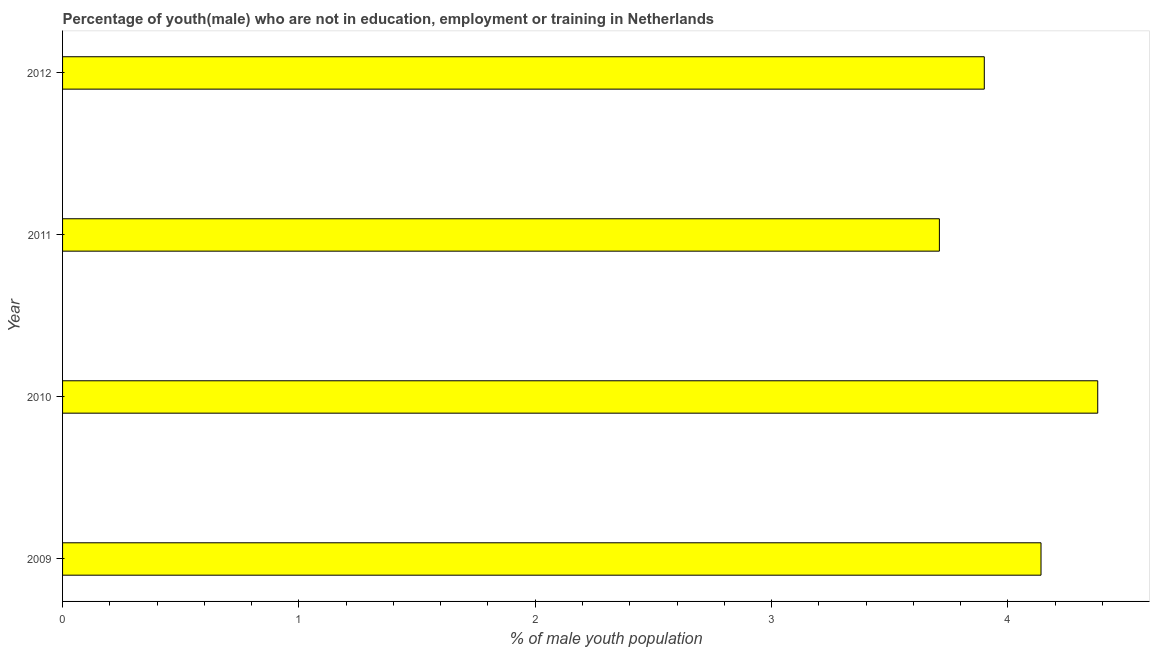What is the title of the graph?
Offer a terse response. Percentage of youth(male) who are not in education, employment or training in Netherlands. What is the label or title of the X-axis?
Give a very brief answer. % of male youth population. What is the label or title of the Y-axis?
Your answer should be very brief. Year. What is the unemployed male youth population in 2011?
Make the answer very short. 3.71. Across all years, what is the maximum unemployed male youth population?
Ensure brevity in your answer.  4.38. Across all years, what is the minimum unemployed male youth population?
Ensure brevity in your answer.  3.71. What is the sum of the unemployed male youth population?
Keep it short and to the point. 16.13. What is the difference between the unemployed male youth population in 2010 and 2011?
Provide a short and direct response. 0.67. What is the average unemployed male youth population per year?
Offer a terse response. 4.03. What is the median unemployed male youth population?
Offer a terse response. 4.02. What is the ratio of the unemployed male youth population in 2010 to that in 2012?
Your answer should be very brief. 1.12. Is the unemployed male youth population in 2011 less than that in 2012?
Provide a short and direct response. Yes. Is the difference between the unemployed male youth population in 2009 and 2011 greater than the difference between any two years?
Give a very brief answer. No. What is the difference between the highest and the second highest unemployed male youth population?
Offer a very short reply. 0.24. Is the sum of the unemployed male youth population in 2009 and 2010 greater than the maximum unemployed male youth population across all years?
Your answer should be very brief. Yes. What is the difference between the highest and the lowest unemployed male youth population?
Offer a terse response. 0.67. In how many years, is the unemployed male youth population greater than the average unemployed male youth population taken over all years?
Keep it short and to the point. 2. Are all the bars in the graph horizontal?
Your answer should be compact. Yes. What is the difference between two consecutive major ticks on the X-axis?
Your response must be concise. 1. Are the values on the major ticks of X-axis written in scientific E-notation?
Offer a terse response. No. What is the % of male youth population in 2009?
Provide a short and direct response. 4.14. What is the % of male youth population of 2010?
Provide a short and direct response. 4.38. What is the % of male youth population of 2011?
Provide a short and direct response. 3.71. What is the % of male youth population in 2012?
Give a very brief answer. 3.9. What is the difference between the % of male youth population in 2009 and 2010?
Offer a terse response. -0.24. What is the difference between the % of male youth population in 2009 and 2011?
Provide a short and direct response. 0.43. What is the difference between the % of male youth population in 2009 and 2012?
Provide a succinct answer. 0.24. What is the difference between the % of male youth population in 2010 and 2011?
Your answer should be compact. 0.67. What is the difference between the % of male youth population in 2010 and 2012?
Give a very brief answer. 0.48. What is the difference between the % of male youth population in 2011 and 2012?
Keep it short and to the point. -0.19. What is the ratio of the % of male youth population in 2009 to that in 2010?
Keep it short and to the point. 0.94. What is the ratio of the % of male youth population in 2009 to that in 2011?
Provide a short and direct response. 1.12. What is the ratio of the % of male youth population in 2009 to that in 2012?
Offer a terse response. 1.06. What is the ratio of the % of male youth population in 2010 to that in 2011?
Provide a succinct answer. 1.18. What is the ratio of the % of male youth population in 2010 to that in 2012?
Keep it short and to the point. 1.12. What is the ratio of the % of male youth population in 2011 to that in 2012?
Keep it short and to the point. 0.95. 